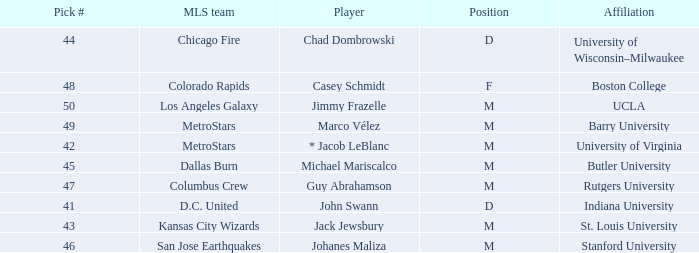Which MLS team has the #41 pick? D.C. United. 